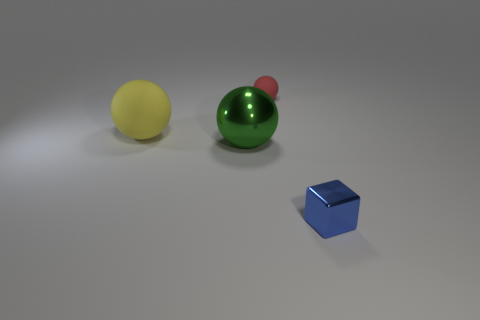What is the material of the tiny thing behind the small metal block to the right of the large yellow sphere?
Give a very brief answer. Rubber. There is a big green object that is made of the same material as the blue block; what shape is it?
Your response must be concise. Sphere. Are there any other things that are the same shape as the small blue object?
Make the answer very short. No. What number of tiny red rubber balls are in front of the tiny red ball?
Your answer should be very brief. 0. Are there any small matte blocks?
Give a very brief answer. No. What is the color of the matte sphere in front of the tiny object that is behind the small object that is in front of the red object?
Provide a succinct answer. Yellow. There is a ball that is left of the green metallic thing; is there a large object that is on the right side of it?
Make the answer very short. Yes. What number of other shiny blocks are the same size as the metallic block?
Offer a terse response. 0. There is a object to the right of the red matte object; is its size the same as the yellow rubber sphere?
Provide a succinct answer. No. The big green thing is what shape?
Your response must be concise. Sphere. 